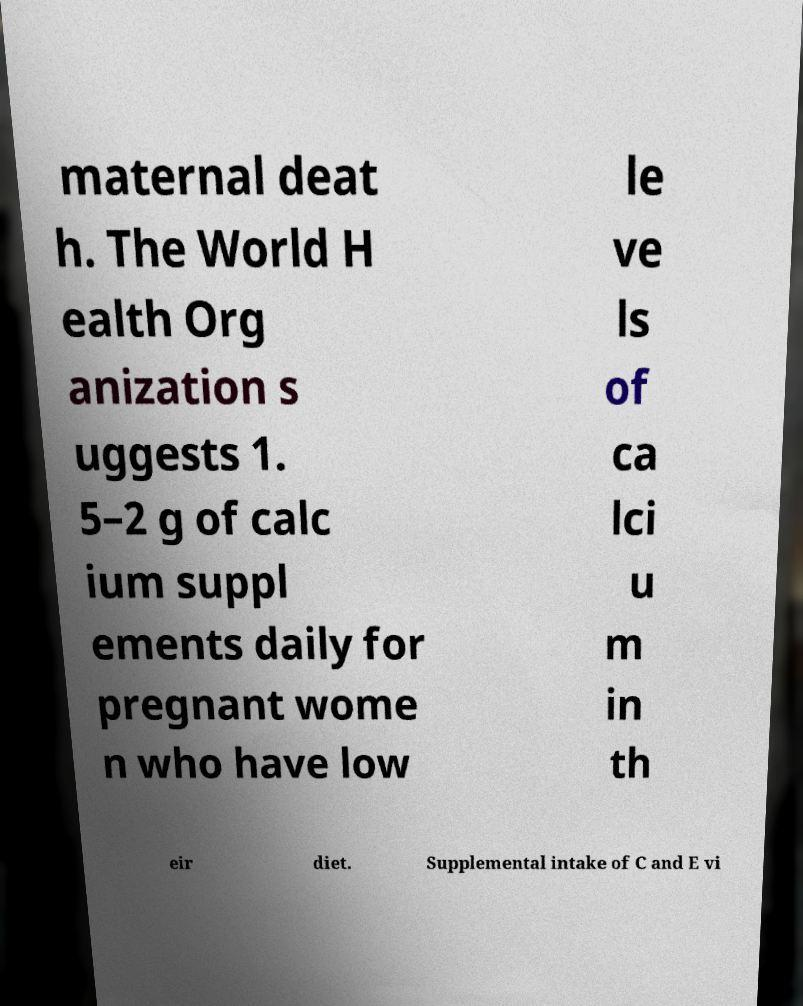Please identify and transcribe the text found in this image. maternal deat h. The World H ealth Org anization s uggests 1. 5–2 g of calc ium suppl ements daily for pregnant wome n who have low le ve ls of ca lci u m in th eir diet. Supplemental intake of C and E vi 